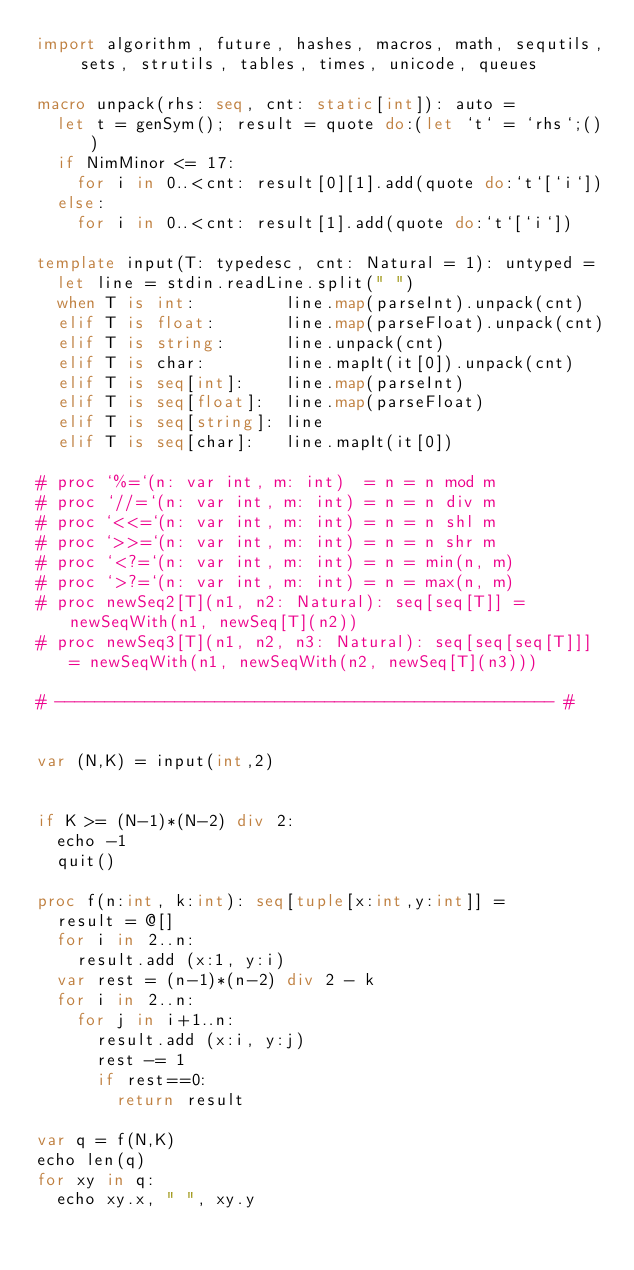<code> <loc_0><loc_0><loc_500><loc_500><_Nim_>import algorithm, future, hashes, macros, math, sequtils, sets, strutils, tables, times, unicode, queues
 
macro unpack(rhs: seq, cnt: static[int]): auto =
  let t = genSym(); result = quote do:(let `t` = `rhs`;())
  if NimMinor <= 17:
    for i in 0..<cnt: result[0][1].add(quote do:`t`[`i`])
  else:
    for i in 0..<cnt: result[1].add(quote do:`t`[`i`])
 
template input(T: typedesc, cnt: Natural = 1): untyped =
  let line = stdin.readLine.split(" ")
  when T is int:         line.map(parseInt).unpack(cnt)
  elif T is float:       line.map(parseFloat).unpack(cnt)
  elif T is string:      line.unpack(cnt)
  elif T is char:        line.mapIt(it[0]).unpack(cnt)
  elif T is seq[int]:    line.map(parseInt)
  elif T is seq[float]:  line.map(parseFloat)
  elif T is seq[string]: line
  elif T is seq[char]:   line.mapIt(it[0])
 
# proc `%=`(n: var int, m: int)  = n = n mod m
# proc `//=`(n: var int, m: int) = n = n div m
# proc `<<=`(n: var int, m: int) = n = n shl m
# proc `>>=`(n: var int, m: int) = n = n shr m
# proc `<?=`(n: var int, m: int) = n = min(n, m)
# proc `>?=`(n: var int, m: int) = n = max(n, m)
# proc newSeq2[T](n1, n2: Natural): seq[seq[T]] = newSeqWith(n1, newSeq[T](n2))
# proc newSeq3[T](n1, n2, n3: Natural): seq[seq[seq[T]]] = newSeqWith(n1, newSeqWith(n2, newSeq[T](n3)))
 
# -------------------------------------------------- #


var (N,K) = input(int,2)


if K >= (N-1)*(N-2) div 2:
  echo -1
  quit()

proc f(n:int, k:int): seq[tuple[x:int,y:int]] =
  result = @[]
  for i in 2..n:
    result.add (x:1, y:i)
  var rest = (n-1)*(n-2) div 2 - k
  for i in 2..n:
    for j in i+1..n:
      result.add (x:i, y:j)
      rest -= 1
      if rest==0:
        return result

var q = f(N,K)
echo len(q)
for xy in q:
  echo xy.x, " ", xy.y</code> 